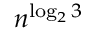<formula> <loc_0><loc_0><loc_500><loc_500>n ^ { \log _ { 2 } 3 }</formula> 